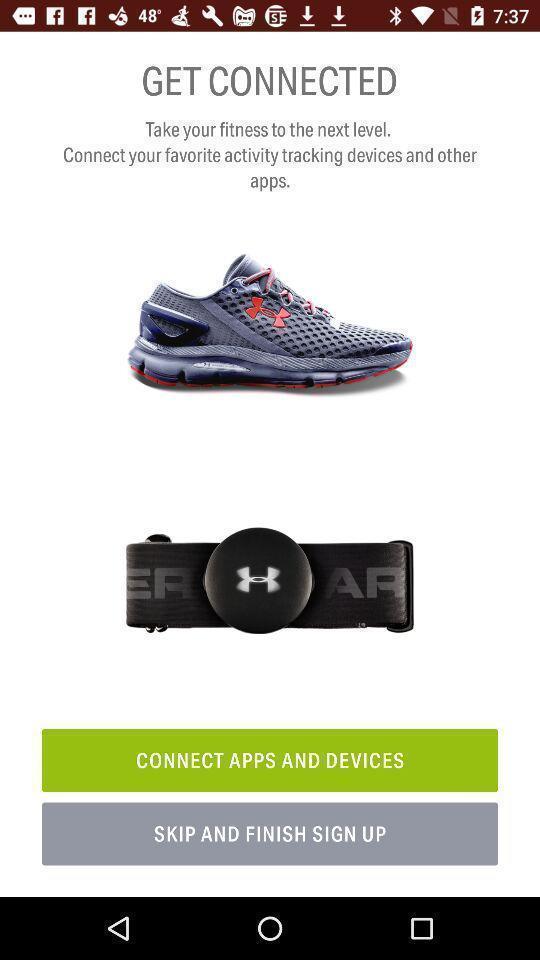Tell me about the visual elements in this screen capture. Sign up page of a fitness app. 